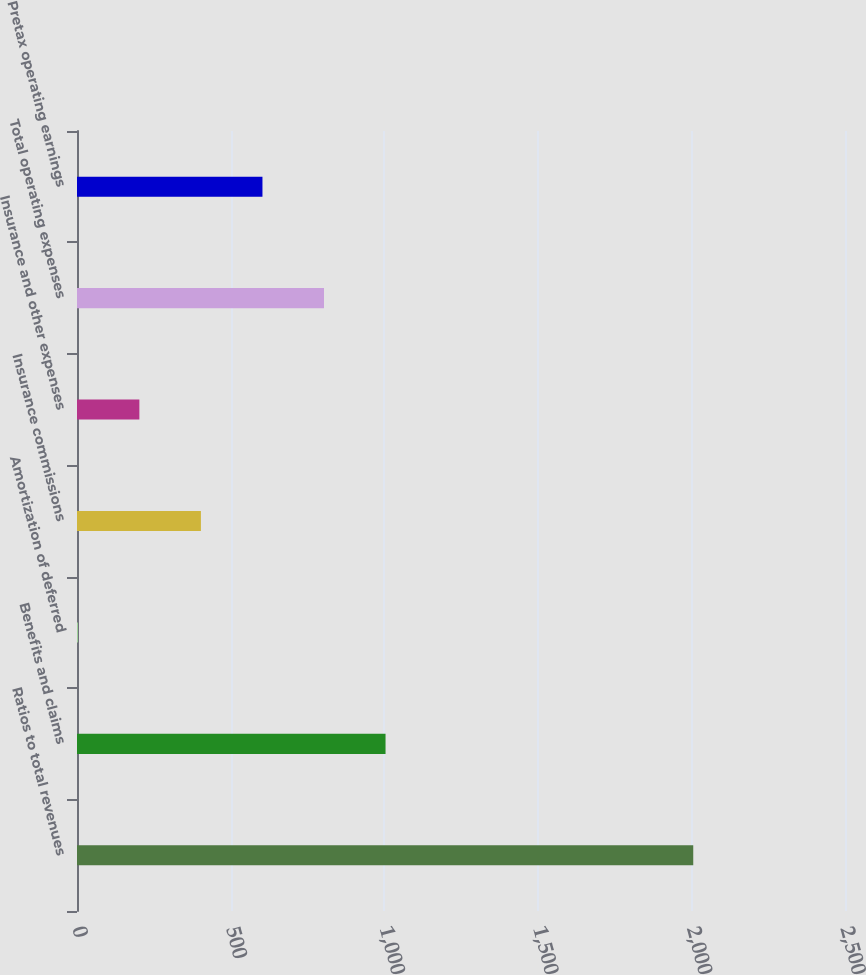Convert chart to OTSL. <chart><loc_0><loc_0><loc_500><loc_500><bar_chart><fcel>Ratios to total revenues<fcel>Benefits and claims<fcel>Amortization of deferred<fcel>Insurance commissions<fcel>Insurance and other expenses<fcel>Total operating expenses<fcel>Pretax operating earnings<nl><fcel>2006<fcel>1004.35<fcel>2.7<fcel>403.36<fcel>203.03<fcel>804.02<fcel>603.69<nl></chart> 